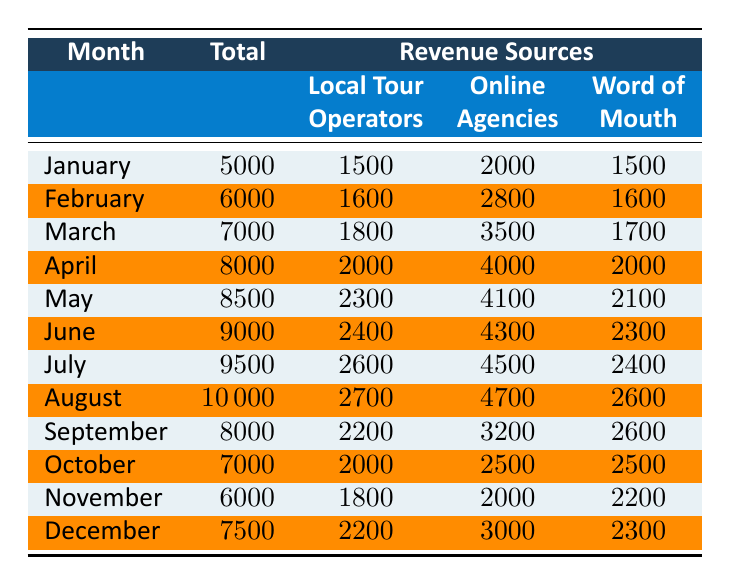What was the total tourist revenue for August? The total tourist revenue for August is read directly from the table under the month of August, which shows a total of 10000.
Answer: 10000 Which month had the highest revenue from local tour operators? By reviewing the amounts listed for local tour operators in each month, the highest value is noted in August with 2700.
Answer: 2700 What is the total revenue from online travel agencies for the entire year? To find the total revenue from online travel agencies, I need to sum the amounts from each month: 2000 + 2800 + 3500 + 4000 + 4100 + 4300 + 4500 + 4700 + 3200 + 2500 + 2000 + 3000 = 39500.
Answer: 39500 Did the total tourist revenue for November exceed 6000? The table shows that the total tourist revenue for November is 6000, which means it did not exceed 6000; it is equal to that amount.
Answer: No Which month had the highest total revenue, and how much was it? By examining the total revenue values, August has the highest total at 10000.
Answer: August, 10000 What is the average total revenue by month for April, May, and June? I need to calculate the total for those three months: 8000 + 8500 + 9000 = 25500. Then, I divide by the number of months (3) to find the average: 25500 / 3 = 8500.
Answer: 8500 What was the difference in total revenue between July and September? To find the difference, I subtract the September total of 8000 from the July total of 9500: 9500 - 8000 = 1500.
Answer: 1500 Was the word-of-mouth revenue for December higher than that for January? The table lists the word-of-mouth revenue for December as 2300 and for January as 1500. Since 2300 is greater than 1500, the statement is true.
Answer: Yes In which month was the revenue from online travel agencies lowest, and what was that revenue? By looking for the lowest figure in the online travel agencies column, I find the value for October is the lowest at 2500.
Answer: October, 2500 